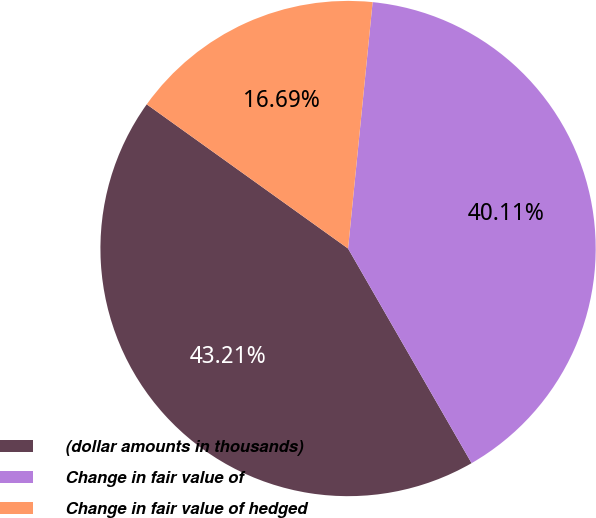<chart> <loc_0><loc_0><loc_500><loc_500><pie_chart><fcel>(dollar amounts in thousands)<fcel>Change in fair value of<fcel>Change in fair value of hedged<nl><fcel>43.21%<fcel>40.11%<fcel>16.69%<nl></chart> 